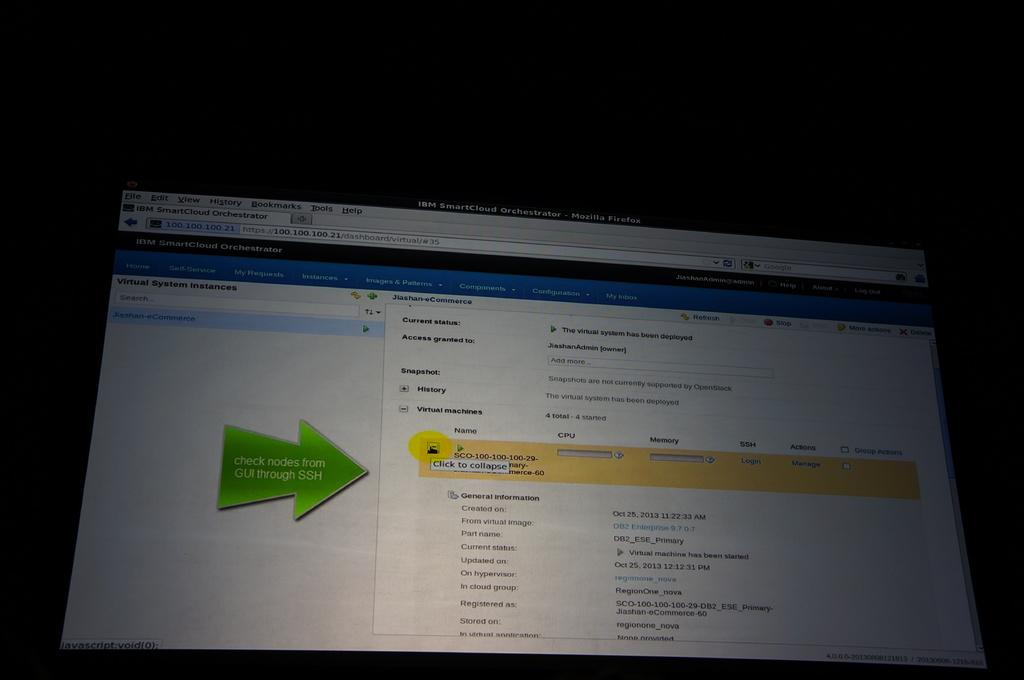<image>
Describe the image concisely. Virtual System Instances are explained from a website on the monitor. 